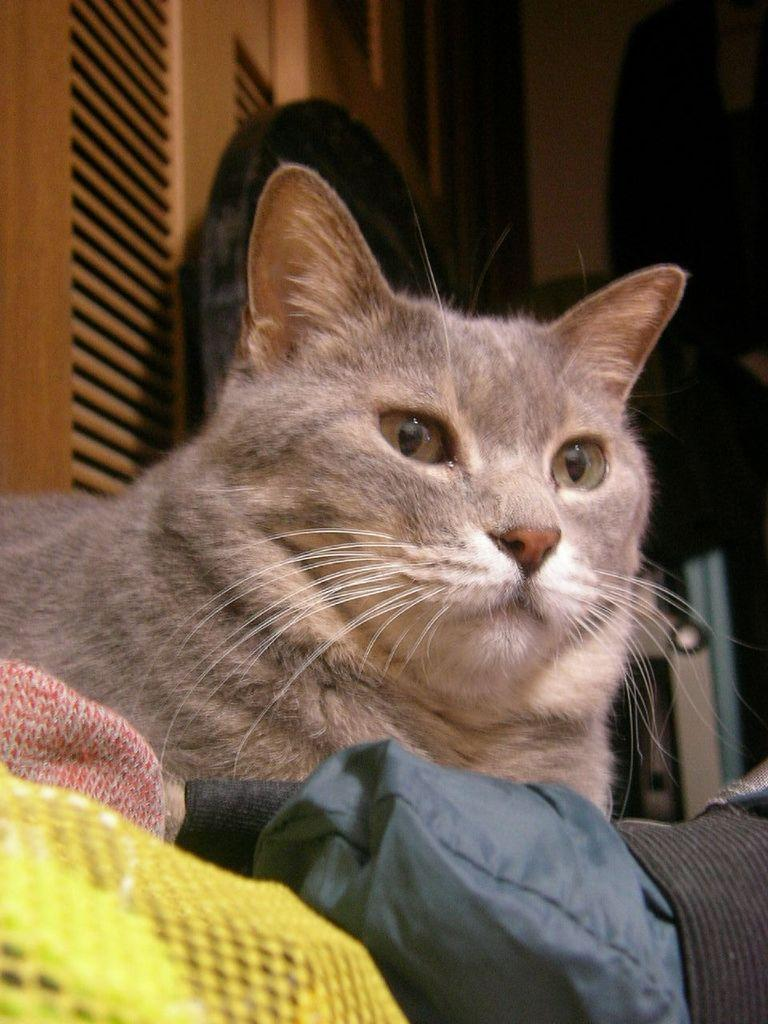What type of animal is present in the image? There is a cat in the image. What else can be seen in the image besides the cat? There are clothes in the image. Can you describe the background of the image? There are objects in the background of the image. What type of silk is the snail using to weave a pattern in the image? There is no snail or silk present in the image. What type of market is visible in the background of the image? There is no market visible in the image; it only shows a cat, clothes, and objects in the background. 